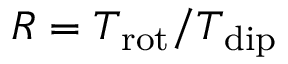Convert formula to latex. <formula><loc_0><loc_0><loc_500><loc_500>R = T _ { r o t } / T _ { d i p }</formula> 